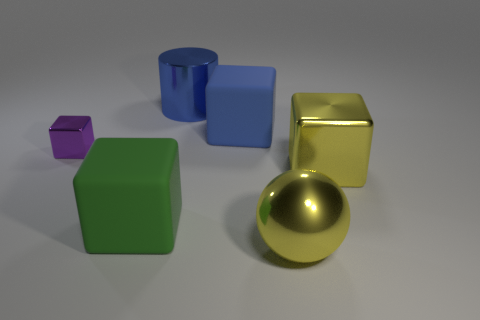What number of objects are the same color as the big ball?
Your answer should be compact. 1. Is there a small purple thing that is in front of the big metallic object that is in front of the big yellow block right of the big metallic sphere?
Provide a succinct answer. No. There is a blue thing that is the same size as the metallic cylinder; what shape is it?
Provide a short and direct response. Cube. How many big objects are cubes or yellow blocks?
Make the answer very short. 3. The tiny block that is made of the same material as the big yellow ball is what color?
Your answer should be compact. Purple. Is the shape of the rubber object that is in front of the purple metal cube the same as the rubber object behind the tiny shiny object?
Ensure brevity in your answer.  Yes. How many rubber things are blue blocks or big green objects?
Provide a short and direct response. 2. What material is the large cube that is the same color as the cylinder?
Keep it short and to the point. Rubber. Is there any other thing that has the same shape as the large blue metal object?
Keep it short and to the point. No. What is the material of the large cube behind the small purple thing?
Provide a succinct answer. Rubber. 